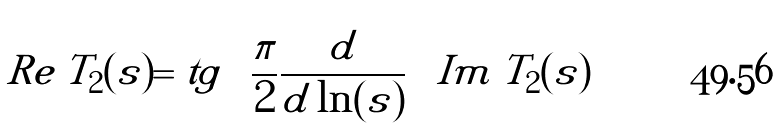Convert formula to latex. <formula><loc_0><loc_0><loc_500><loc_500>R e \, T _ { 2 } ( s ) = t g \left ( \frac { \pi } { 2 } \frac { d } { d \ln ( s ) } \right ) I m \, T _ { 2 } ( s )</formula> 